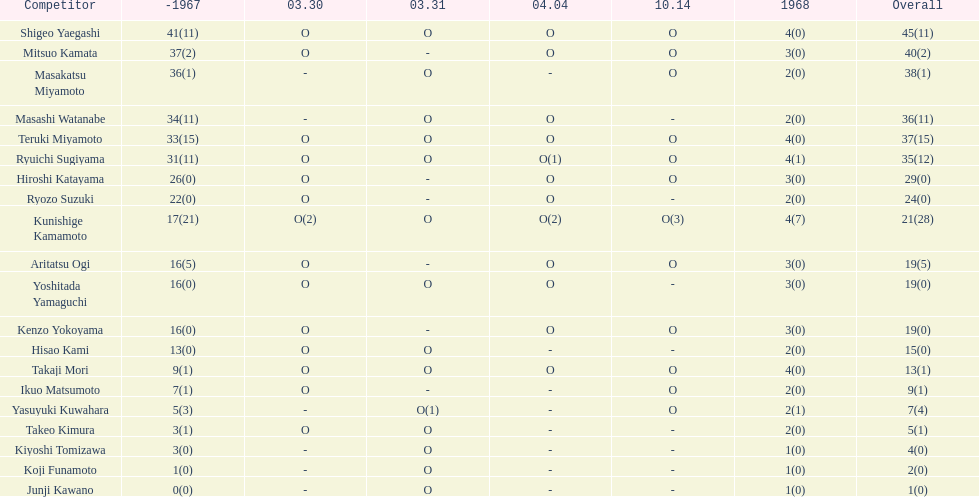Overall participations by masakatsu miyamoto? 38. 